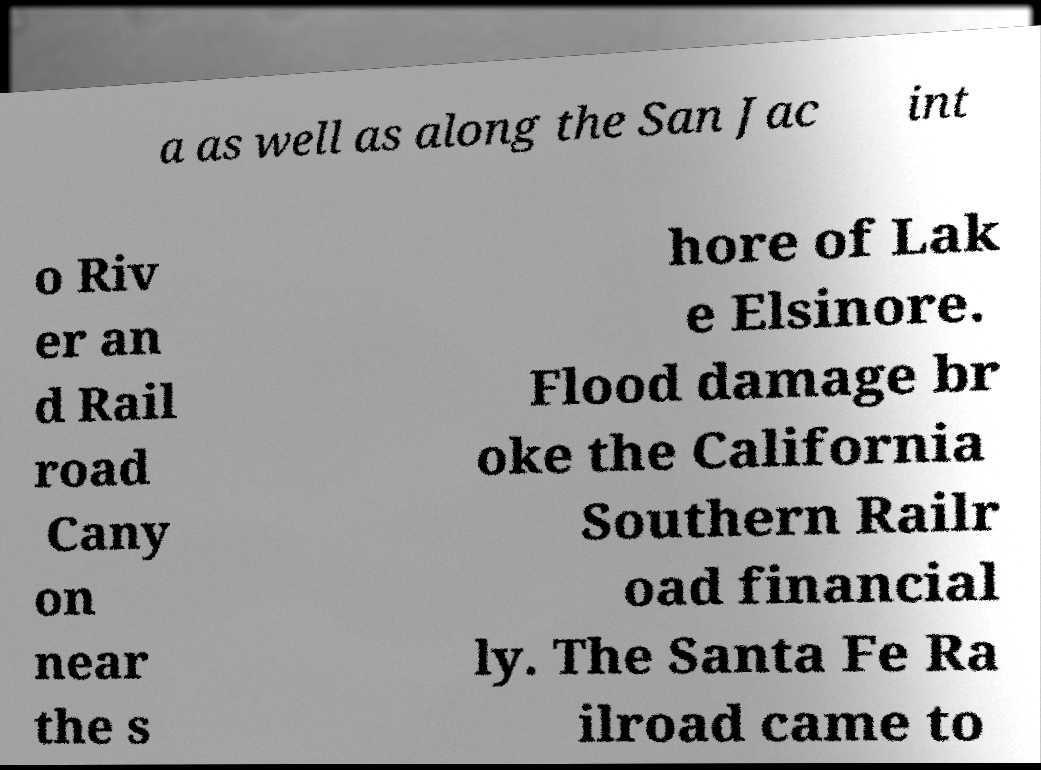There's text embedded in this image that I need extracted. Can you transcribe it verbatim? a as well as along the San Jac int o Riv er an d Rail road Cany on near the s hore of Lak e Elsinore. Flood damage br oke the California Southern Railr oad financial ly. The Santa Fe Ra ilroad came to 